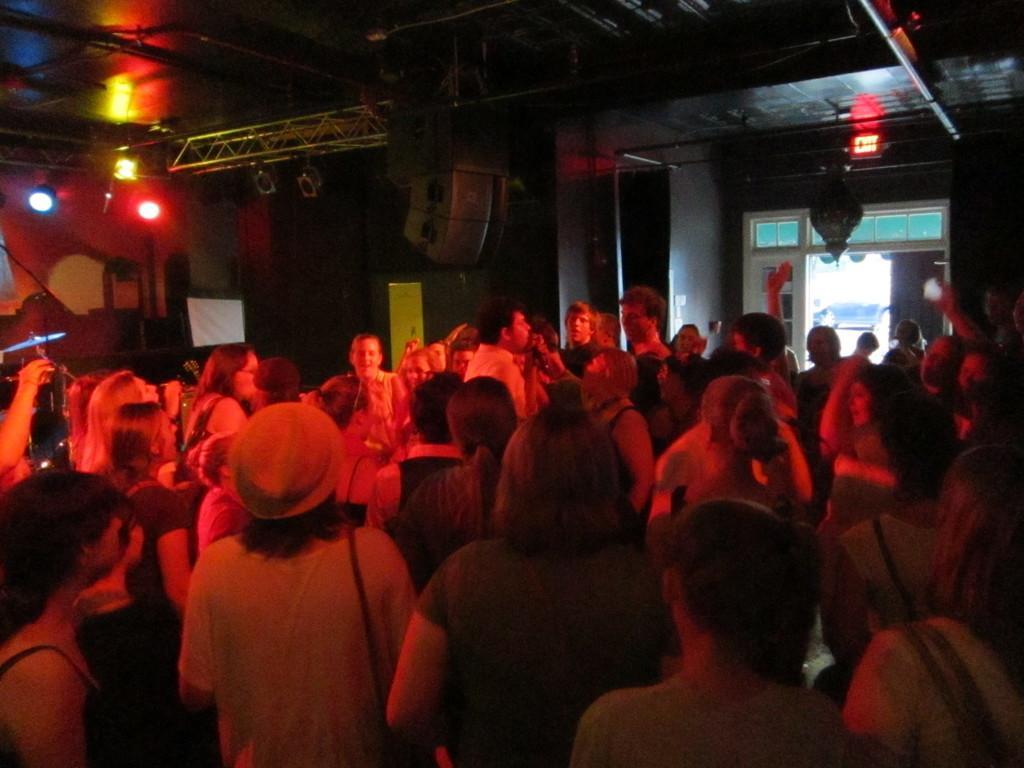In one or two sentences, can you explain what this image depicts? This picture is clicked in the concert hall. In this picture, we see many people are standing. On the left side, we see the musical instruments. In the background, we see the lights, stand and a wall. We see the banners of the boards in white and yellow color. On the right side, we see an exit board and a door from which we can see a black car. 